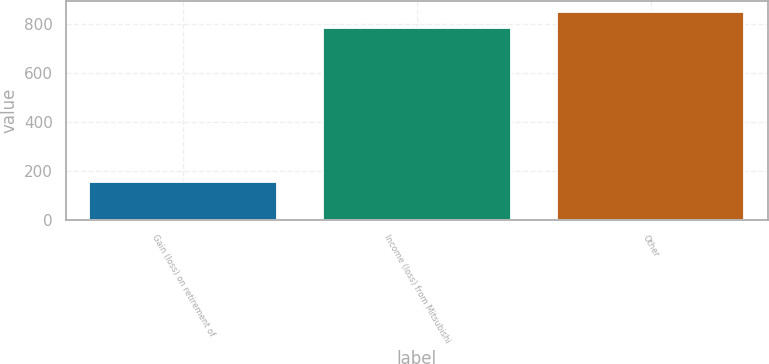Convert chart. <chart><loc_0><loc_0><loc_500><loc_500><bar_chart><fcel>Gain (loss) on retirement of<fcel>Income (loss) from Mitsubishi<fcel>Other<nl><fcel>155<fcel>783<fcel>850.8<nl></chart> 